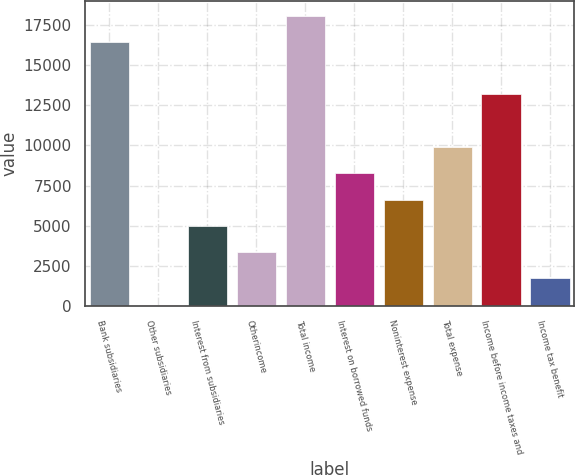Convert chart. <chart><loc_0><loc_0><loc_500><loc_500><bar_chart><fcel>Bank subsidiaries<fcel>Other subsidiaries<fcel>Interest from subsidiaries<fcel>Otherincome<fcel>Total income<fcel>Interest on borrowed funds<fcel>Noninterest expense<fcel>Total expense<fcel>Income before income taxes and<fcel>Income tax benefit<nl><fcel>16465<fcel>63<fcel>4983.6<fcel>3343.4<fcel>18105.2<fcel>8264<fcel>6623.8<fcel>9904.2<fcel>13184.6<fcel>1703.2<nl></chart> 